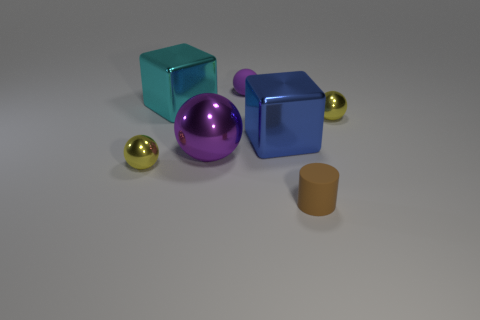Add 3 shiny things. How many objects exist? 10 Subtract all blocks. How many objects are left? 5 Add 2 purple metal spheres. How many purple metal spheres are left? 3 Add 1 tiny yellow shiny objects. How many tiny yellow shiny objects exist? 3 Subtract 0 red cylinders. How many objects are left? 7 Subtract all tiny brown matte objects. Subtract all big yellow cubes. How many objects are left? 6 